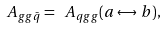<formula> <loc_0><loc_0><loc_500><loc_500>\ A _ { g g \bar { q } } = \ A _ { q g g } ( a \leftrightarrow b ) ,</formula> 